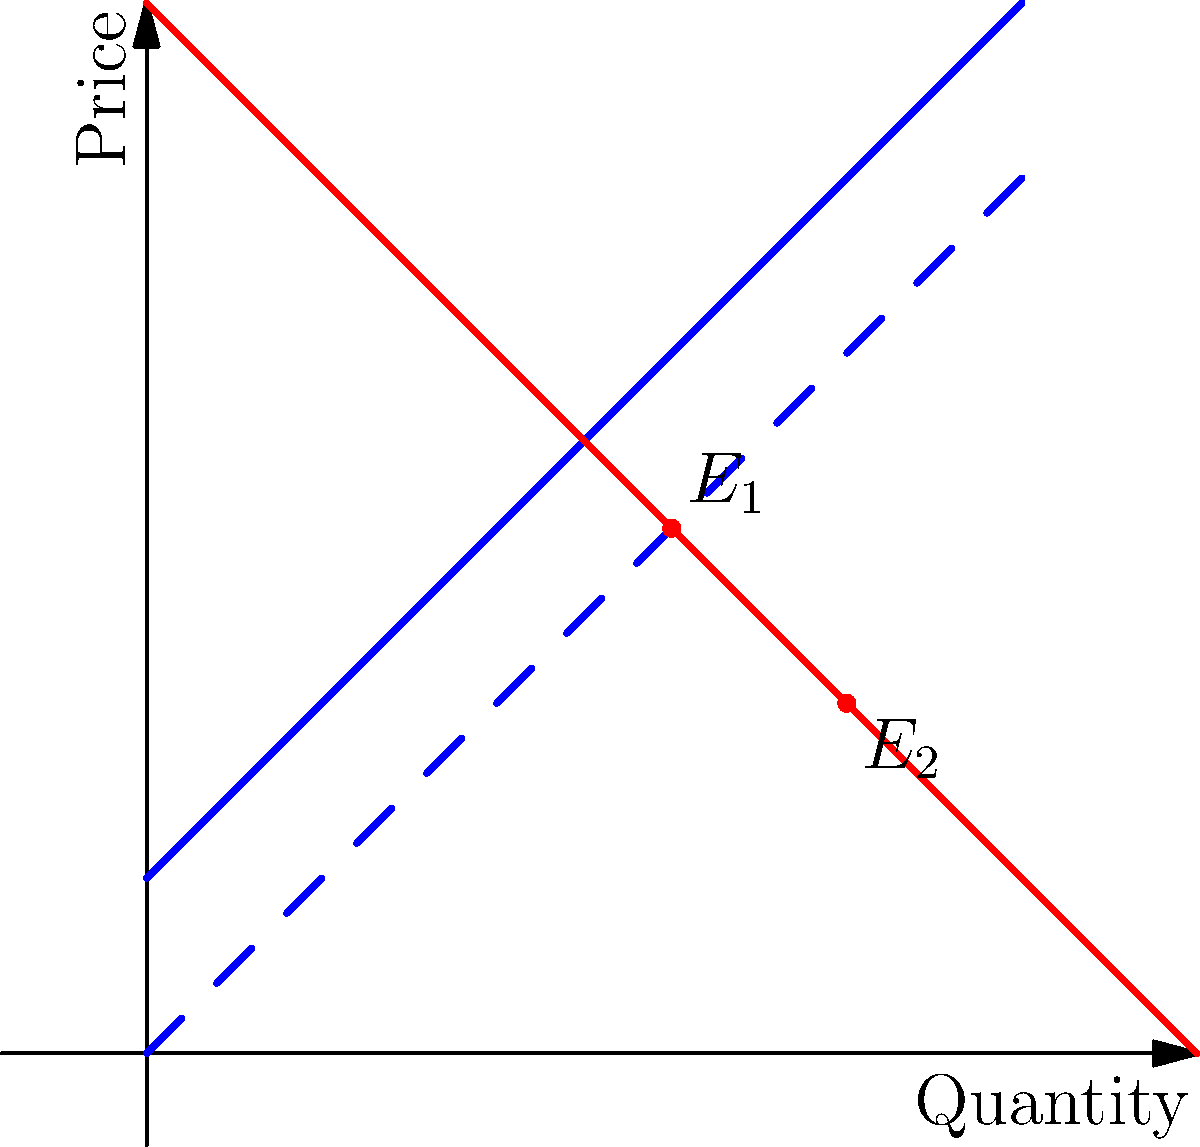In the graph above, the original supply curve shifts downward, representing a decrease in production costs. As a liberal economist, how would you interpret the change in consumer surplus resulting from this shift? Express your answer in terms of the change in area. To analyze the change in consumer surplus as a liberal economist, we'll follow these steps:

1. Identify the initial and final equilibrium points:
   - Initial equilibrium $E_1$ is at the intersection of the original supply curve and the demand curve.
   - New equilibrium $E_2$ is at the intersection of the new supply curve and the demand curve.

2. Define consumer surplus:
   Consumer surplus is the area below the demand curve and above the price line.

3. Calculate the change in consumer surplus:
   - Initial consumer surplus: Area of triangle above $E_1$ up to the demand curve
   - New consumer surplus: Area of triangle above $E_2$ up to the demand curve
   - Change in consumer surplus: Difference between these two areas

4. Interpret the change:
   The new equilibrium point $E_2$ is lower and to the right of $E_1$, indicating:
   - Lower price
   - Higher quantity demanded

5. Economic interpretation:
   - As a liberal economist, we would view this positively as it increases consumer welfare.
   - The increase in consumer surplus represents a gain for consumers, aligning with the liberal economic view of prioritizing consumer benefits.
   - This shift could be seen as a result of improved production efficiency or technological advancement, which liberal economists often advocate for.

6. Policy implications:
   - Support policies that encourage cost-reducing innovations in production.
   - Advocate for measures that pass cost savings to consumers, enhancing overall economic welfare.

The change in consumer surplus is represented by the area of the trapezoid bounded by the two equilibrium prices, between the demand curve and the price axis.
Answer: Increase in consumer surplus equal to the area of the trapezoid between $E_1$ and $E_2$, bounded by the demand curve and price axis. 